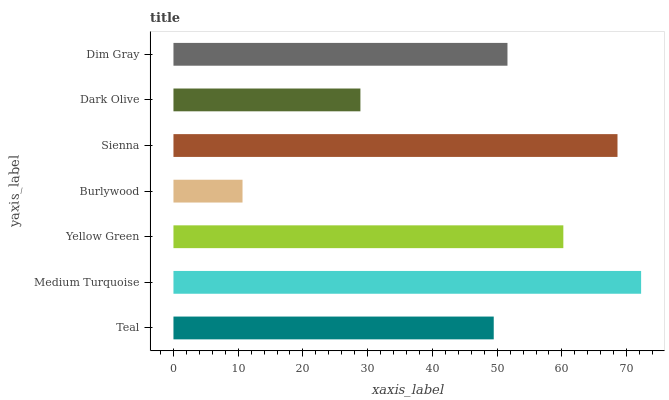Is Burlywood the minimum?
Answer yes or no. Yes. Is Medium Turquoise the maximum?
Answer yes or no. Yes. Is Yellow Green the minimum?
Answer yes or no. No. Is Yellow Green the maximum?
Answer yes or no. No. Is Medium Turquoise greater than Yellow Green?
Answer yes or no. Yes. Is Yellow Green less than Medium Turquoise?
Answer yes or no. Yes. Is Yellow Green greater than Medium Turquoise?
Answer yes or no. No. Is Medium Turquoise less than Yellow Green?
Answer yes or no. No. Is Dim Gray the high median?
Answer yes or no. Yes. Is Dim Gray the low median?
Answer yes or no. Yes. Is Burlywood the high median?
Answer yes or no. No. Is Dark Olive the low median?
Answer yes or no. No. 